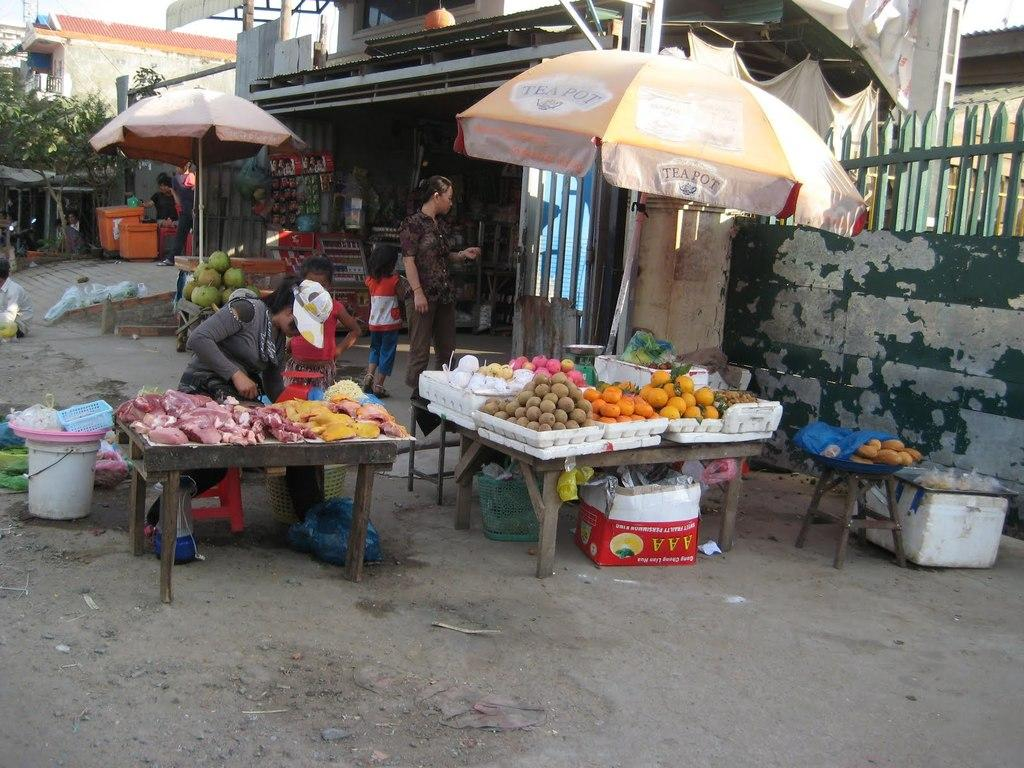What is the woman doing in the image? The woman is sitting on a table and selling things. What is the purpose of the umbrella in the image? The umbrella is likely used for shade or protection from the sun or rain. What type of items is the woman selling? The image shows fruits, so it is likely that the woman is selling fruits. Where is the faucet located in the image? There is no faucet present in the image. What type of soap is the woman using to clean the fruits? There is no soap or cleaning activity depicted in the image. 